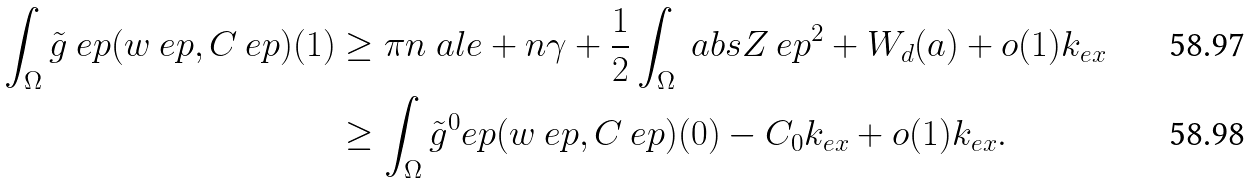Convert formula to latex. <formula><loc_0><loc_0><loc_500><loc_500>\int _ { \Omega } \tilde { g } _ { \ } e p ( w _ { \ } e p , C _ { \ } e p ) ( 1 ) & \geq \pi n \ a l e + n \gamma + \frac { 1 } { 2 } \int _ { \Omega } \ a b s { Z _ { \ } e p } ^ { 2 } + W _ { d } ( a ) + o ( 1 ) k _ { e x } \\ & \geq \int _ { \Omega } \tilde { g } ^ { 0 } _ { \ } e p ( w _ { \ } e p , C _ { \ } e p ) ( 0 ) - C _ { 0 } k _ { e x } + o ( 1 ) k _ { e x } .</formula> 